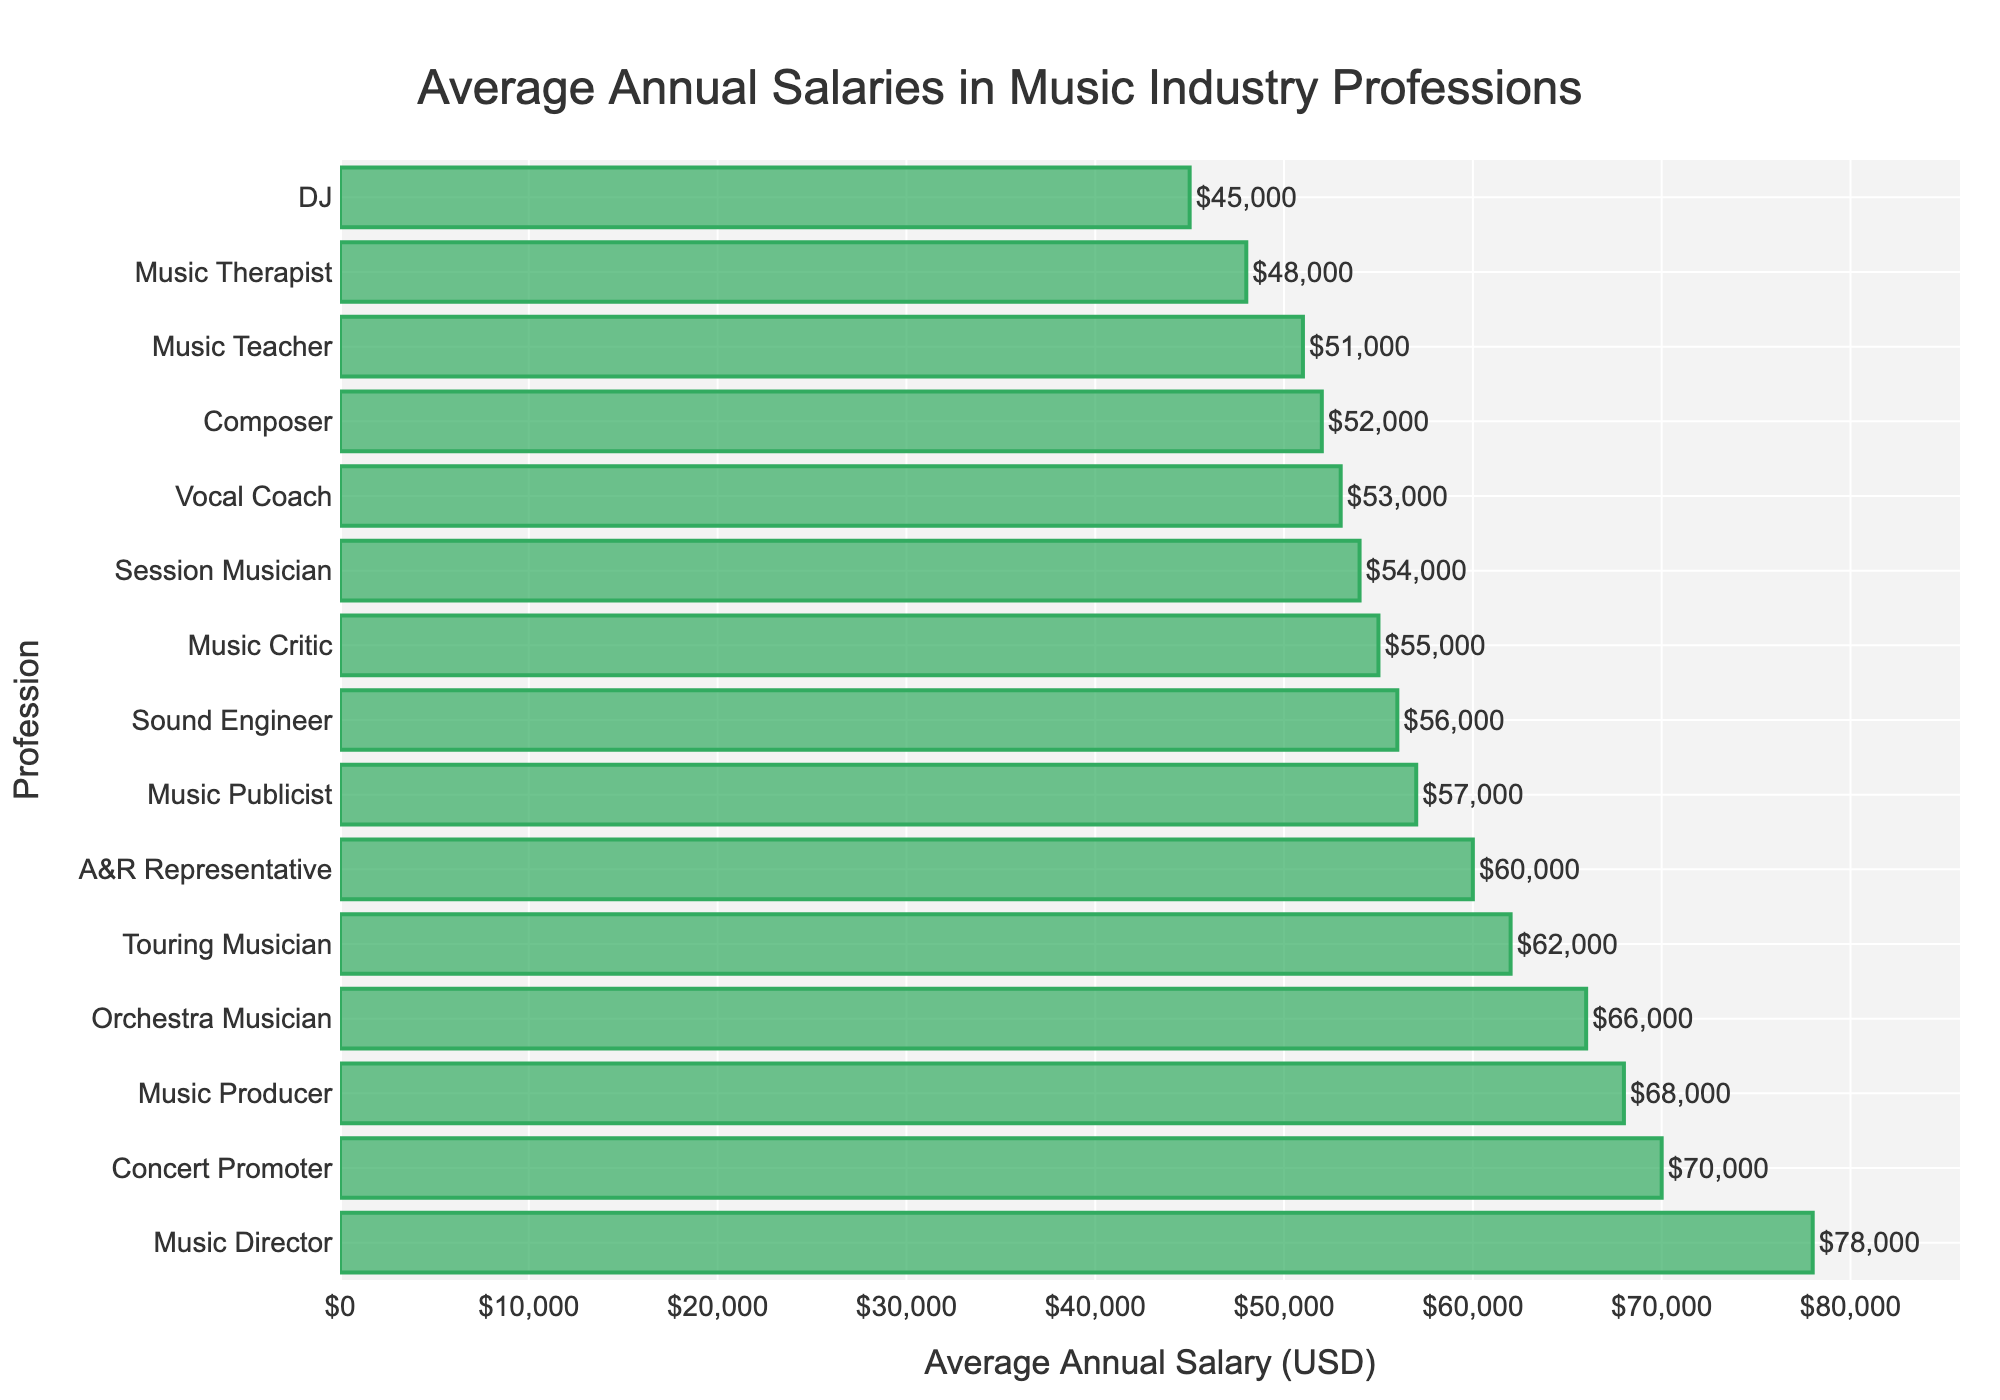What's the highest average annual salary among the music industry professions? Looking at the highest bar in the chart will reveal the profession with the highest average annual salary. The tallest bar corresponds to the Music Director.
Answer: Music Director Which profession has a higher average annual salary, a Music Teacher or a Composer? Compare the lengths of the bars associated with Music Teacher and Composer. The bar for Composer is longer than the one for Music Teacher.
Answer: Composer How much more does a Concert Promoter earn on average compared to a DJ annually? Find the bars for Concert Promoter and DJ, and note their lengths. Subtract the average annual salary of the DJ from that of the Concert Promoter. $70000 - $45000 = $25000
Answer: $25000 What is the average annual salary of an Orchestra Musician compared to a Sound Engineer? Look at the bars corresponding to Orchestra Musician and Sound Engineer. The bar for Orchestra Musician is longer, indicating a higher average annual salary.
Answer: Orchestra Musician What are the top three highest-paying professions listed in the chart? Identify the top three tallest bars in the chart. The top three are Music Director, Concert Promoter, and Music Producer.
Answer: Music Director, Concert Promoter, Music Producer Between a Music Publicist and an A&R Representative, who earns more on average annually and by how much? Compare the heights of the bars for Music Publicist and A&R Representative. The bar for A&R Representative is longer. Calculate the difference in their average annual salaries: $60000 - $57000 = $3000
Answer: A&R Representative, $3000 Which has the lowest average annual salary, and what is it? Find the shortest bar in the chart to determine the lowest average annual salary. The shortest bar corresponds to the DJ.
Answer: DJ, $45000 What is the combined average annual salary of a Music Therapist and a Vocal Coach? Add the average annual salaries indicated by the bars for Music Therapist and Vocal Coach. $48000 + $53000 = $101000
Answer: $101000 What are the average annual salaries of the professions that earn more than $60000? Identify the bars with lengths indicating salaries greater than $60000. These professions and their salaries are: Music Director ($78000), Concert Promoter ($70000), Music Producer ($68000), Orchestra Musician ($66000), and Touring Musician ($62000).
Answer: Music Director, $78000; Concert Promoter, $70000; Music Producer, $68000; Orchestra Musician, $66000; Touring Musician, $62000 How many professions have an average annual salary between $50000 and $60000? Count the number of bars that fall within the $50000 to $60000 range. These include Composer, Sound Engineer, Vocal Coach, Music Publicist, and Music Critic.
Answer: 5 